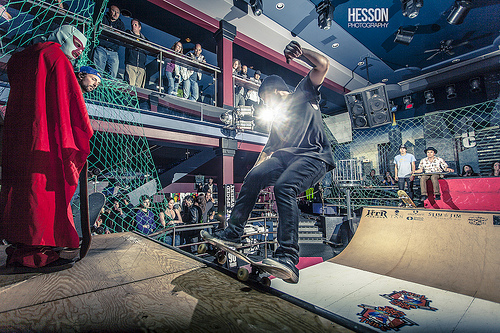<image>
Can you confirm if the guy is on the skateboard? No. The guy is not positioned on the skateboard. They may be near each other, but the guy is not supported by or resting on top of the skateboard. 